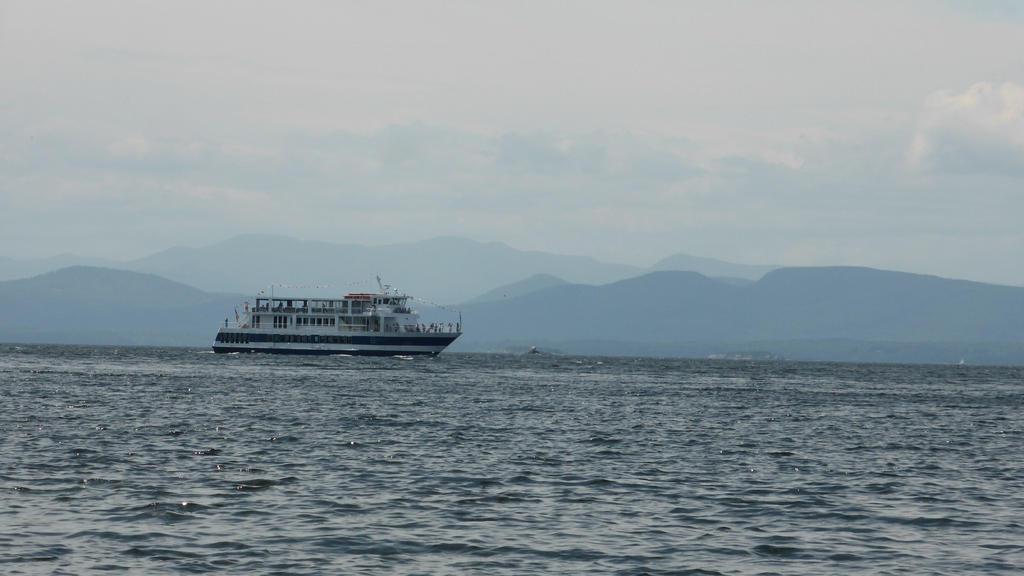In one or two sentences, can you explain what this image depicts? In the image we can see a ship in the water, we can even see there are mountains and a cloudy sky. 